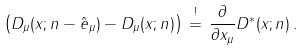Convert formula to latex. <formula><loc_0><loc_0><loc_500><loc_500>\left ( D _ { \mu } ( { x } ; { n } - \hat { e } _ { \mu } ) - D _ { \mu } ( { x } ; { n } ) \right ) \, \stackrel { ! } { = } \, \frac { \partial } { \partial x _ { \mu } } D ^ { * } ( { x } ; { n } ) \, .</formula> 